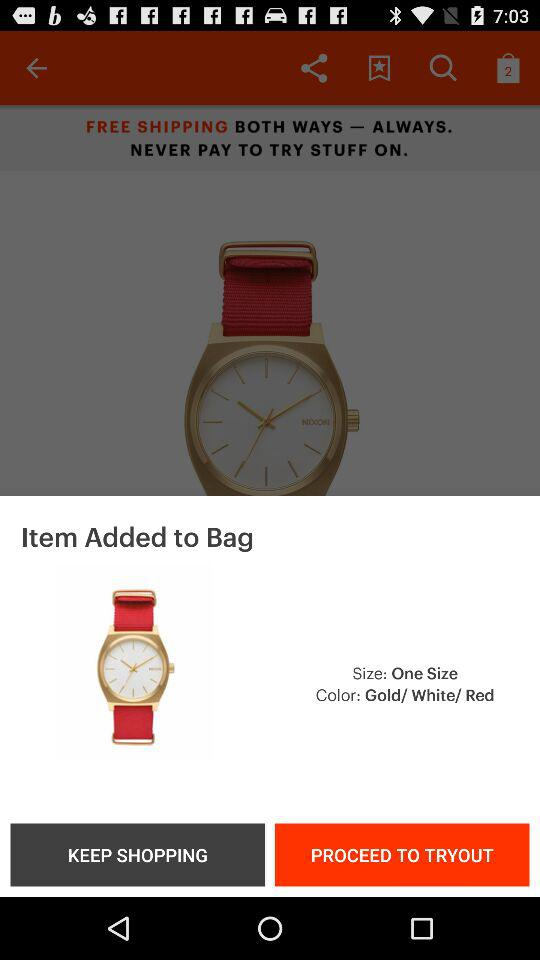How many colors does the watch come in?
Answer the question using a single word or phrase. 3 